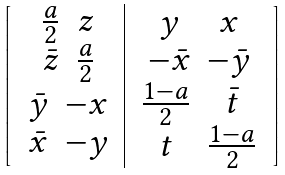Convert formula to latex. <formula><loc_0><loc_0><loc_500><loc_500>\left [ \begin{array} { c | c } \begin{array} { c c } \frac { a } { 2 } & z \\ \bar { z } & \frac { a } { 2 } \end{array} & \begin{array} { c c } y & x \\ - \bar { x } & - \bar { y } \end{array} \\ \begin{array} { c c } \bar { y } & - x \\ \bar { x } & - y \end{array} & \begin{array} { c c } \frac { 1 - a } { 2 } & \bar { t } \\ t & \frac { 1 - a } { 2 } \end{array} \end{array} \right ]</formula> 